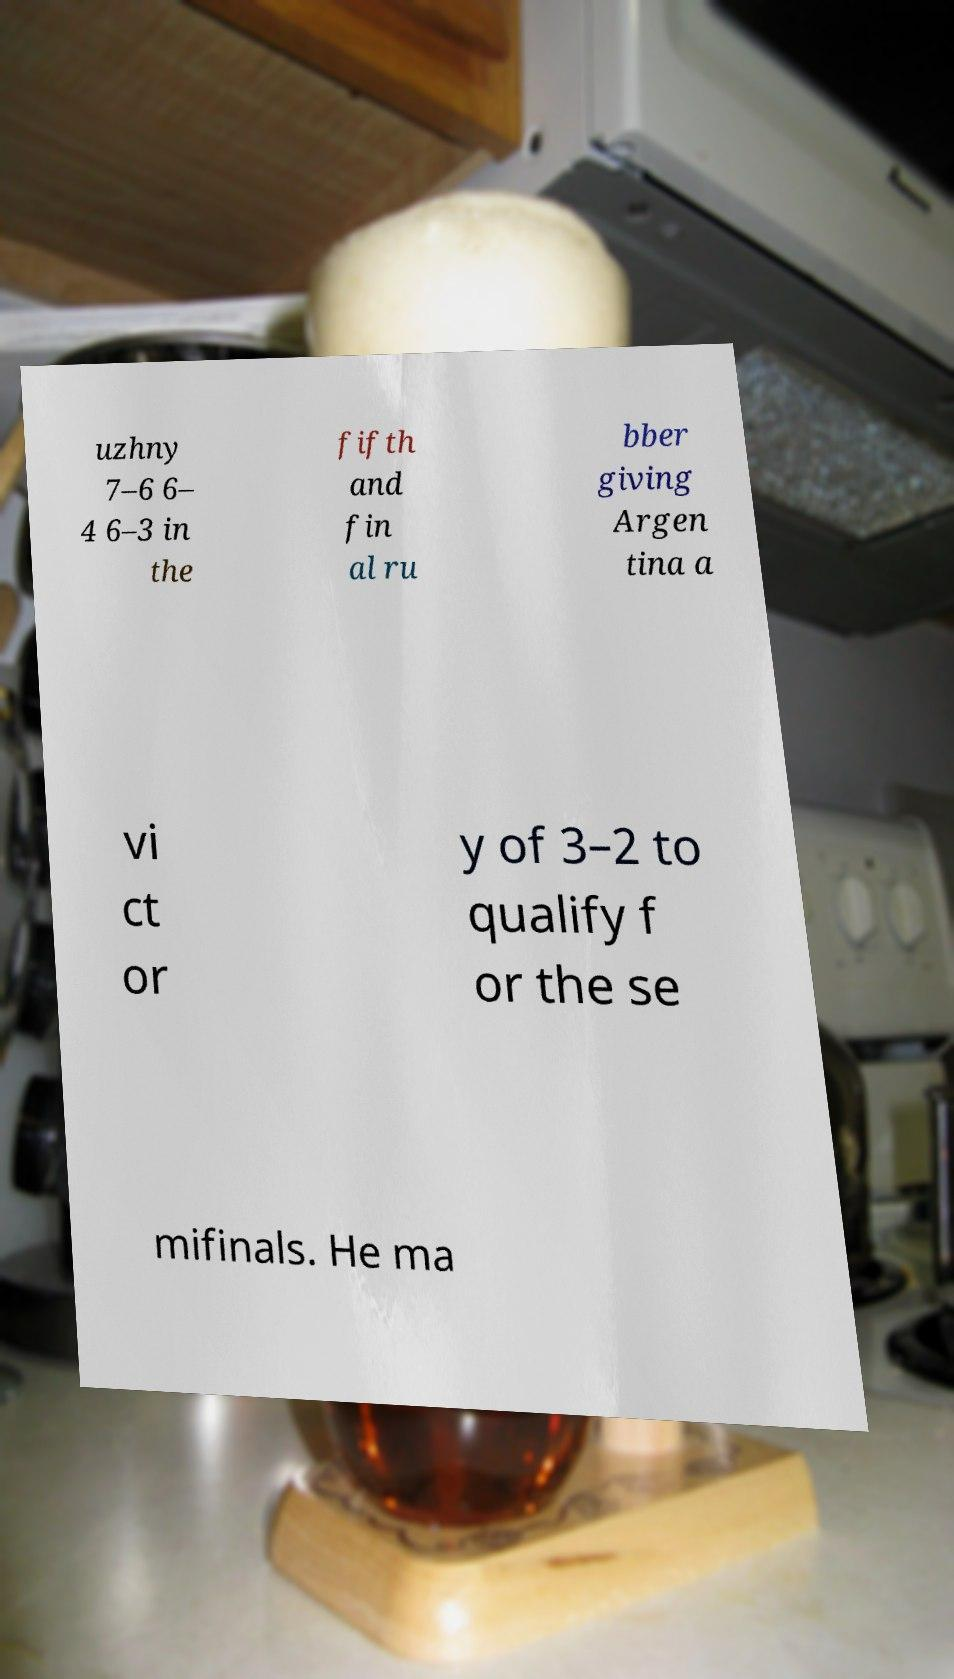Can you read and provide the text displayed in the image?This photo seems to have some interesting text. Can you extract and type it out for me? uzhny 7–6 6– 4 6–3 in the fifth and fin al ru bber giving Argen tina a vi ct or y of 3–2 to qualify f or the se mifinals. He ma 